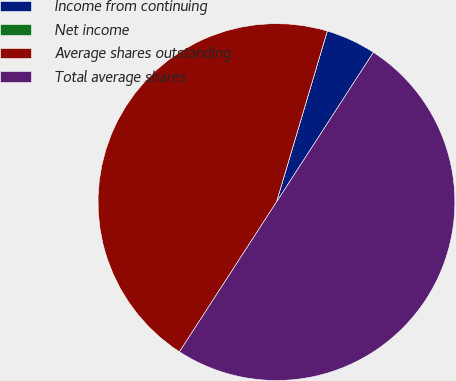Convert chart. <chart><loc_0><loc_0><loc_500><loc_500><pie_chart><fcel>Income from continuing<fcel>Net income<fcel>Average shares outstanding<fcel>Total average shares<nl><fcel>4.55%<fcel>0.0%<fcel>45.45%<fcel>50.0%<nl></chart> 